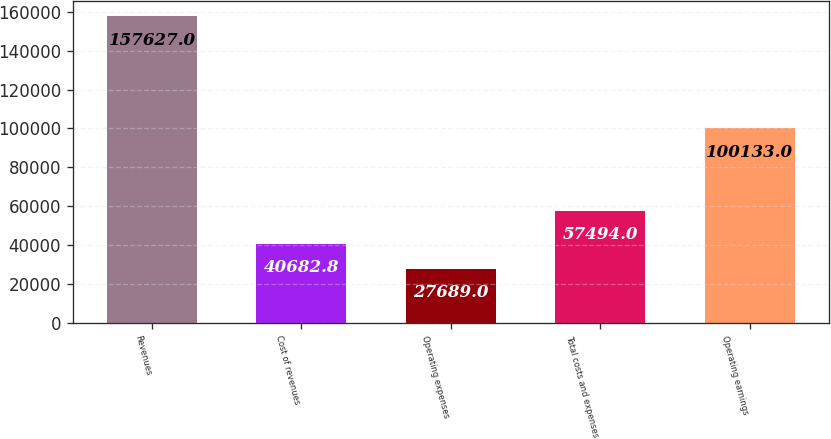Convert chart. <chart><loc_0><loc_0><loc_500><loc_500><bar_chart><fcel>Revenues<fcel>Cost of revenues<fcel>Operating expenses<fcel>Total costs and expenses<fcel>Operating earnings<nl><fcel>157627<fcel>40682.8<fcel>27689<fcel>57494<fcel>100133<nl></chart> 